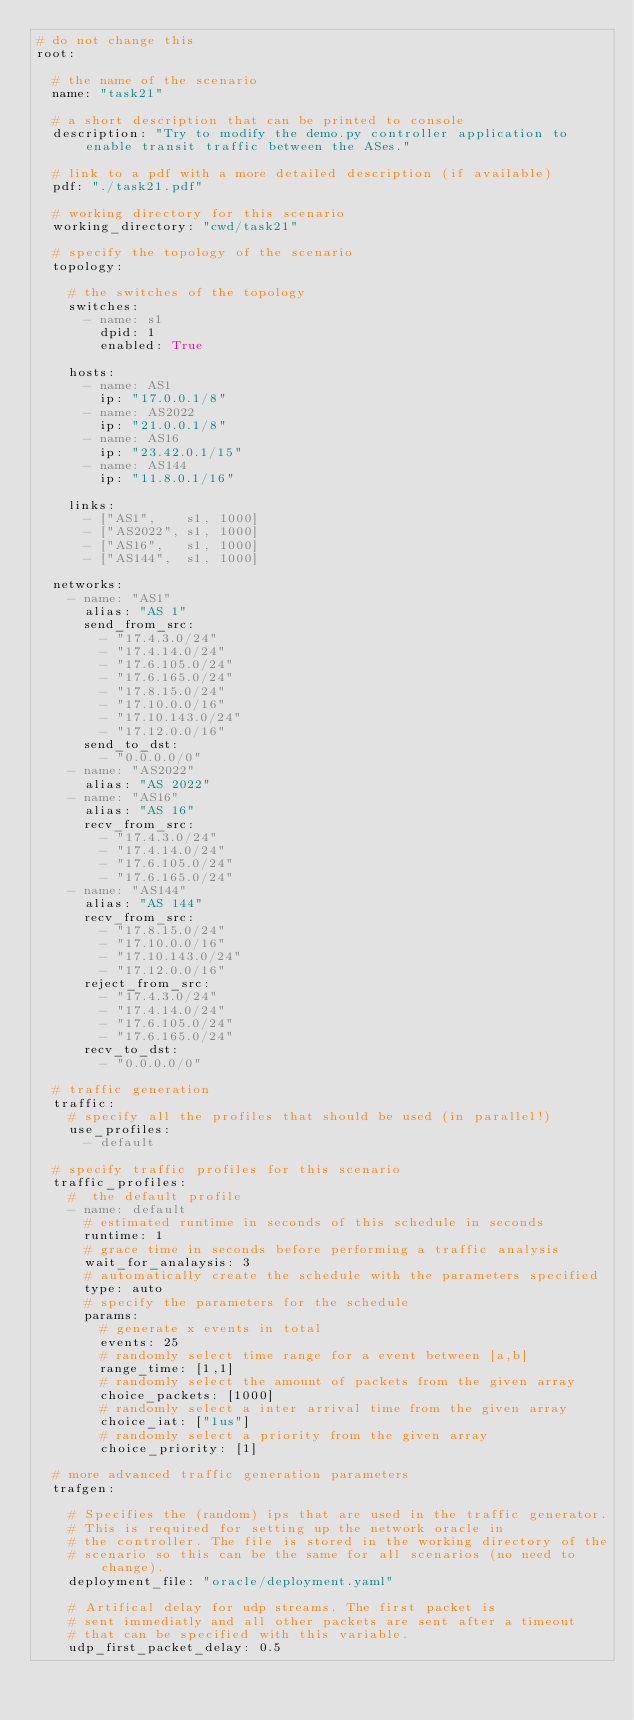Convert code to text. <code><loc_0><loc_0><loc_500><loc_500><_YAML_># do not change this
root:

  # the name of the scenario
  name: "task21"

  # a short description that can be printed to console
  description: "Try to modify the demo.py controller application to enable transit traffic between the ASes."

  # link to a pdf with a more detailed description (if available)
  pdf: "./task21.pdf"

  # working directory for this scenario
  working_directory: "cwd/task21"

  # specify the topology of the scenario
  topology:

    # the switches of the topology
    switches:
      - name: s1
        dpid: 1
        enabled: True

    hosts:
      - name: AS1
        ip: "17.0.0.1/8"
      - name: AS2022
        ip: "21.0.0.1/8"
      - name: AS16
        ip: "23.42.0.1/15"
      - name: AS144
        ip: "11.8.0.1/16"

    links:
      - ["AS1",    s1, 1000]
      - ["AS2022", s1, 1000]
      - ["AS16",   s1, 1000]
      - ["AS144",  s1, 1000]

  networks:
    - name: "AS1"
      alias: "AS 1"
      send_from_src:
        - "17.4.3.0/24"
        - "17.4.14.0/24"
        - "17.6.105.0/24"
        - "17.6.165.0/24"
        - "17.8.15.0/24"
        - "17.10.0.0/16"
        - "17.10.143.0/24"
        - "17.12.0.0/16"
      send_to_dst:
        - "0.0.0.0/0"
    - name: "AS2022"
      alias: "AS 2022"
    - name: "AS16"
      alias: "AS 16"
      recv_from_src:
        - "17.4.3.0/24"
        - "17.4.14.0/24"
        - "17.6.105.0/24"
        - "17.6.165.0/24"
    - name: "AS144"
      alias: "AS 144"
      recv_from_src:
        - "17.8.15.0/24"
        - "17.10.0.0/16"
        - "17.10.143.0/24"
        - "17.12.0.0/16"
      reject_from_src:
        - "17.4.3.0/24"
        - "17.4.14.0/24"
        - "17.6.105.0/24"
        - "17.6.165.0/24"
      recv_to_dst:
        - "0.0.0.0/0"

  # traffic generation
  traffic:
    # specify all the profiles that should be used (in parallel!)
    use_profiles:
      - default

  # specify traffic profiles for this scenario
  traffic_profiles:
    #  the default profile
    - name: default
      # estimated runtime in seconds of this schedule in seconds
      runtime: 1
      # grace time in seconds before performing a traffic analysis
      wait_for_analaysis: 3
      # automatically create the schedule with the parameters specified
      type: auto
      # specify the parameters for the schedule
      params: 
        # generate x events in total
        events: 25
        # randomly select time range for a event between [a,b]
        range_time: [1,1] 
        # randomly select the amount of packets from the given array
        choice_packets: [1000]
        # randomly select a inter arrival time from the given array
        choice_iat: ["1us"]
        # randomly select a priority from the given array
        choice_priority: [1]

  # more advanced traffic generation parameters
  trafgen:

    # Specifies the (random) ips that are used in the traffic generator.
    # This is required for setting up the network oracle in 
    # the controller. The file is stored in the working directory of the
    # scenario so this can be the same for all scenarios (no need to change).
    deployment_file: "oracle/deployment.yaml"
    
    # Artifical delay for udp streams. The first packet is
    # sent immediatly and all other packets are sent after a timeout
    # that can be specified with this variable.
    udp_first_packet_delay: 0.5
</code> 